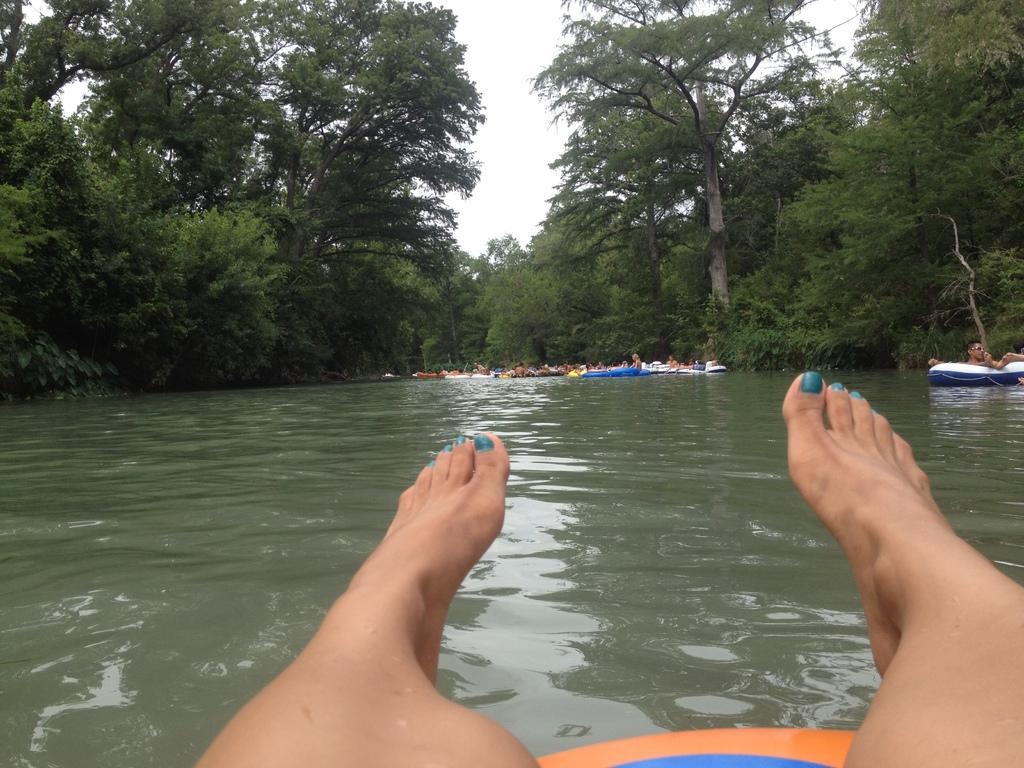Could you give a brief overview of what you see in this image? We can see person legs and water. Far we can see people and boats. In the background we can see trees and sky. 